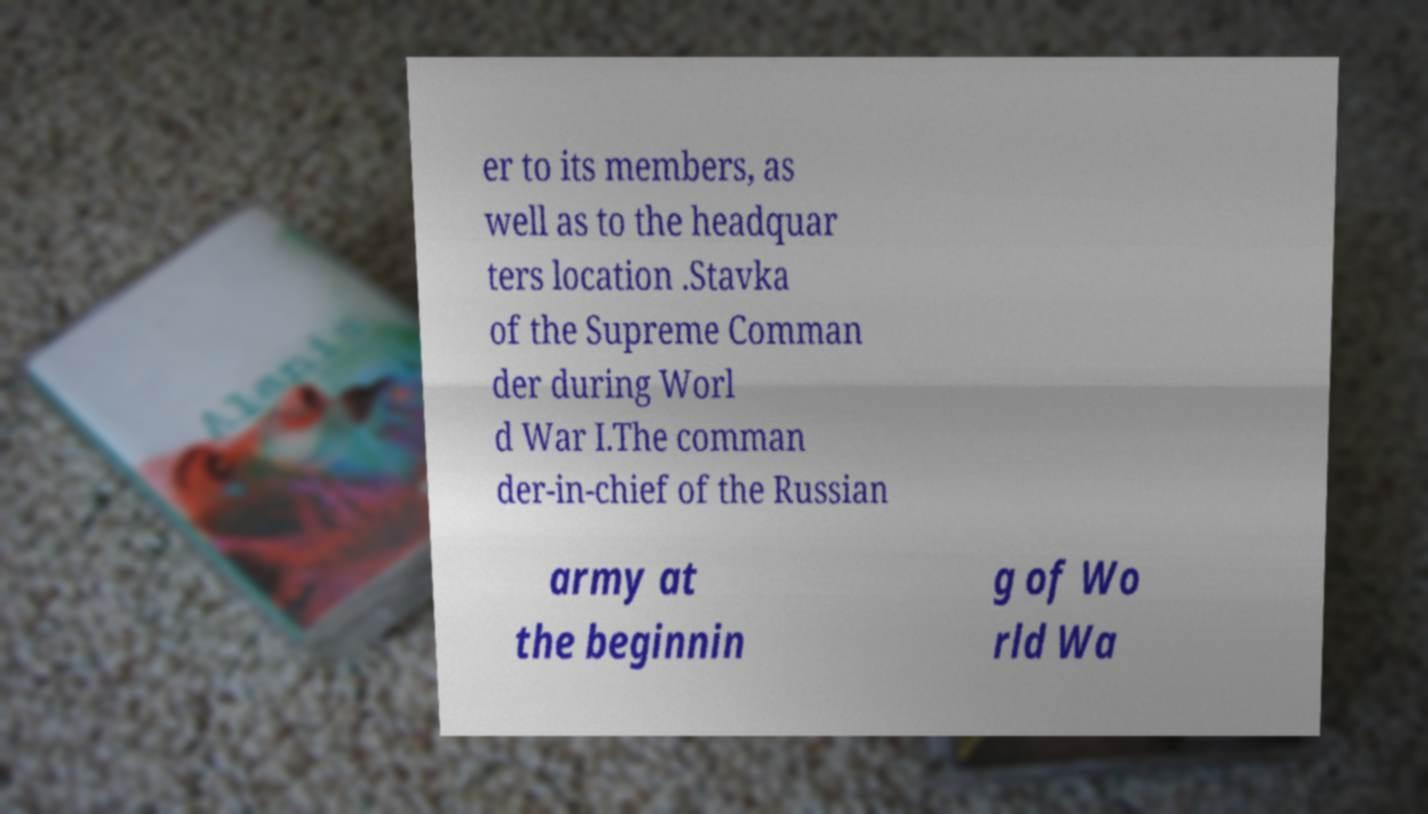Could you extract and type out the text from this image? er to its members, as well as to the headquar ters location .Stavka of the Supreme Comman der during Worl d War I.The comman der-in-chief of the Russian army at the beginnin g of Wo rld Wa 